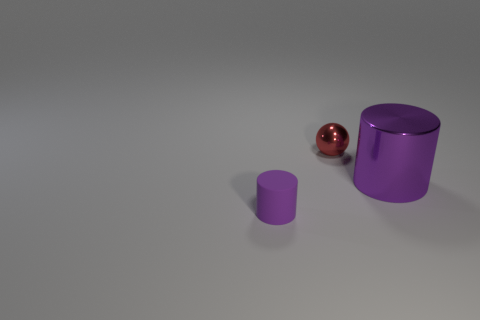Is there a big purple thing that has the same material as the tiny red sphere?
Provide a succinct answer. Yes. There is a large object that is the same color as the small rubber cylinder; what shape is it?
Ensure brevity in your answer.  Cylinder. What number of small cylinders are there?
Offer a very short reply. 1. What number of cylinders are small purple things or small metallic things?
Keep it short and to the point. 1. There is a metal thing that is the same size as the rubber cylinder; what color is it?
Offer a terse response. Red. How many things are in front of the big purple metallic object and behind the large cylinder?
Provide a short and direct response. 0. What is the tiny cylinder made of?
Your answer should be very brief. Rubber. What number of things are small purple cylinders or red things?
Give a very brief answer. 2. Does the purple cylinder to the right of the tiny cylinder have the same size as the purple cylinder that is in front of the purple shiny cylinder?
Provide a short and direct response. No. What number of other things are there of the same size as the rubber cylinder?
Ensure brevity in your answer.  1. 